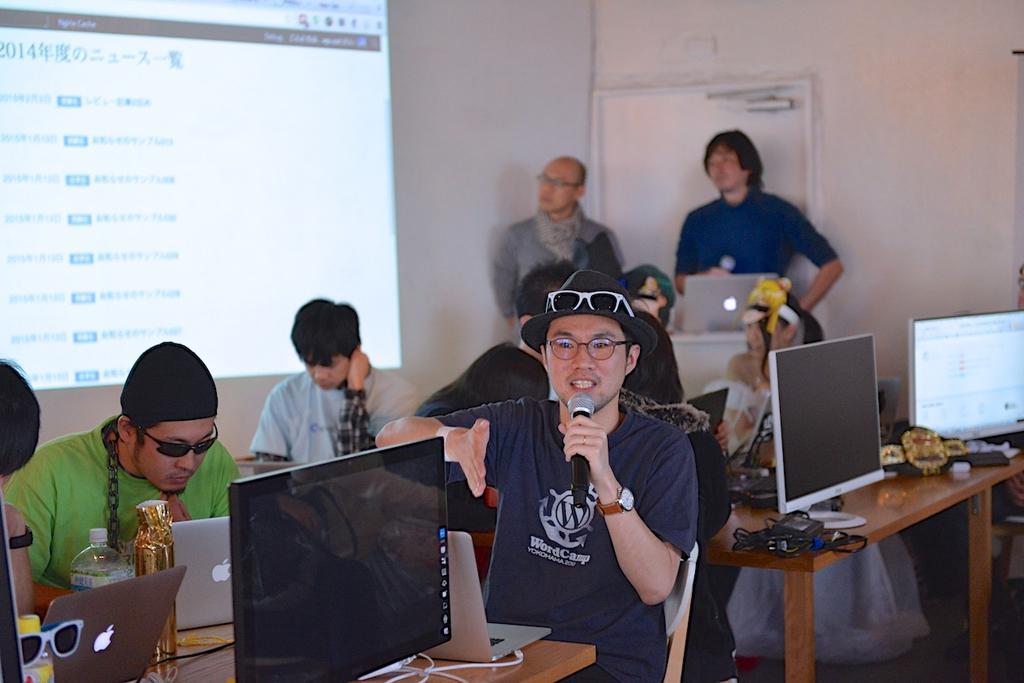Please provide a concise description of this image. In this picture we can see there are some people standing and some people are sitting on chairs and in front of the people there are monitors, laptops, bottles, cables and other things. Behind the people there is a screen and a wall. 